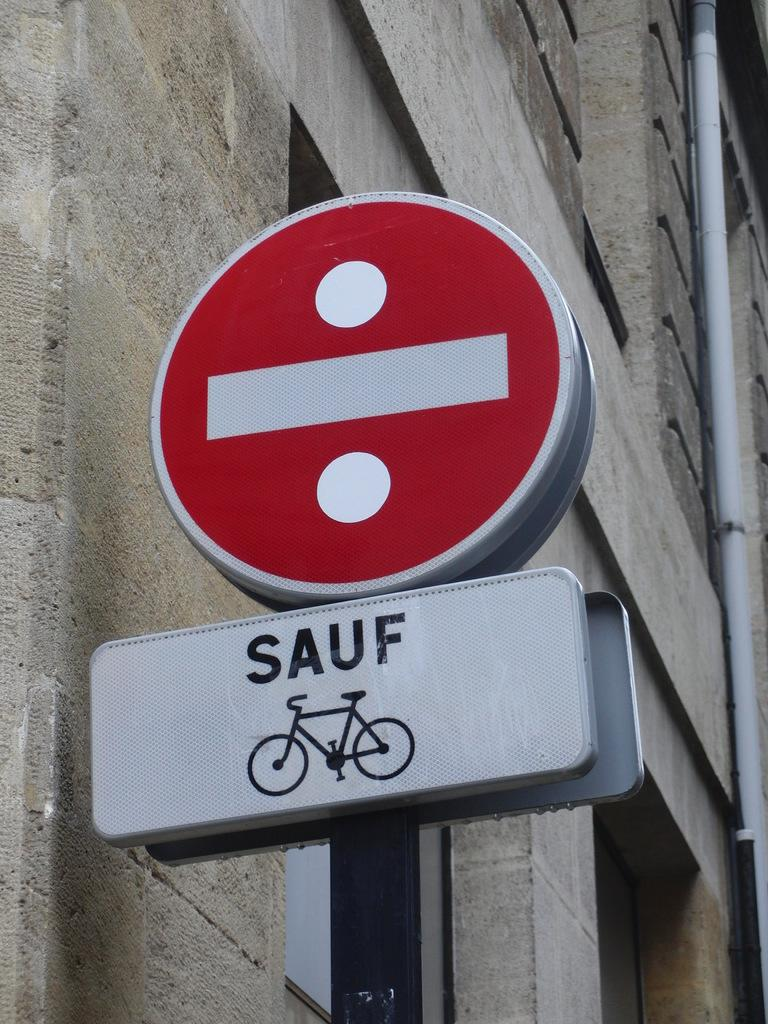<image>
Describe the image concisely. A red and white sign with another white sign below it that says SAUF. 